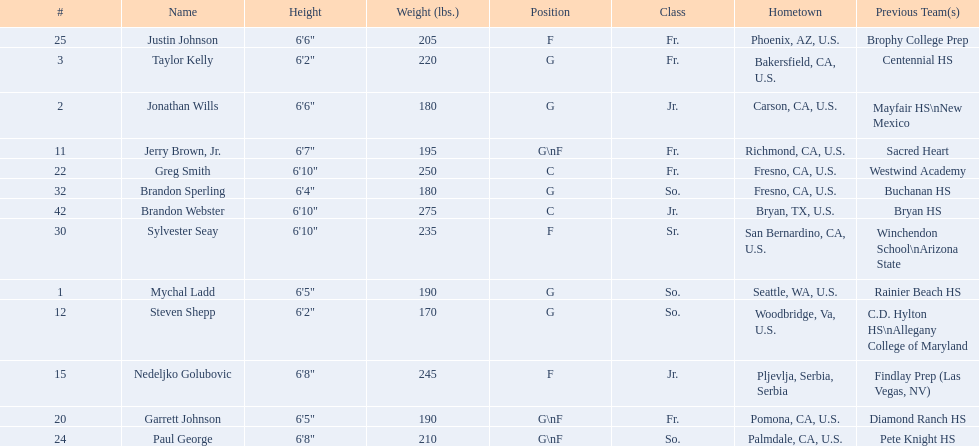Who are the players for the 2009-10 fresno state bulldogs men's basketball team? Mychal Ladd, Jonathan Wills, Taylor Kelly, Jerry Brown, Jr., Steven Shepp, Nedeljko Golubovic, Garrett Johnson, Greg Smith, Paul George, Justin Johnson, Sylvester Seay, Brandon Sperling, Brandon Webster. What are their heights? 6'5", 6'6", 6'2", 6'7", 6'2", 6'8", 6'5", 6'10", 6'8", 6'6", 6'10", 6'4", 6'10". Can you give me this table as a dict? {'header': ['#', 'Name', 'Height', 'Weight (lbs.)', 'Position', 'Class', 'Hometown', 'Previous Team(s)'], 'rows': [['25', 'Justin Johnson', '6\'6"', '205', 'F', 'Fr.', 'Phoenix, AZ, U.S.', 'Brophy College Prep'], ['3', 'Taylor Kelly', '6\'2"', '220', 'G', 'Fr.', 'Bakersfield, CA, U.S.', 'Centennial HS'], ['2', 'Jonathan Wills', '6\'6"', '180', 'G', 'Jr.', 'Carson, CA, U.S.', 'Mayfair HS\\nNew Mexico'], ['11', 'Jerry Brown, Jr.', '6\'7"', '195', 'G\\nF', 'Fr.', 'Richmond, CA, U.S.', 'Sacred Heart'], ['22', 'Greg Smith', '6\'10"', '250', 'C', 'Fr.', 'Fresno, CA, U.S.', 'Westwind Academy'], ['32', 'Brandon Sperling', '6\'4"', '180', 'G', 'So.', 'Fresno, CA, U.S.', 'Buchanan HS'], ['42', 'Brandon Webster', '6\'10"', '275', 'C', 'Jr.', 'Bryan, TX, U.S.', 'Bryan HS'], ['30', 'Sylvester Seay', '6\'10"', '235', 'F', 'Sr.', 'San Bernardino, CA, U.S.', 'Winchendon School\\nArizona State'], ['1', 'Mychal Ladd', '6\'5"', '190', 'G', 'So.', 'Seattle, WA, U.S.', 'Rainier Beach HS'], ['12', 'Steven Shepp', '6\'2"', '170', 'G', 'So.', 'Woodbridge, Va, U.S.', 'C.D. Hylton HS\\nAllegany College of Maryland'], ['15', 'Nedeljko Golubovic', '6\'8"', '245', 'F', 'Jr.', 'Pljevlja, Serbia, Serbia', 'Findlay Prep (Las Vegas, NV)'], ['20', 'Garrett Johnson', '6\'5"', '190', 'G\\nF', 'Fr.', 'Pomona, CA, U.S.', 'Diamond Ranch HS'], ['24', 'Paul George', '6\'8"', '210', 'G\\nF', 'So.', 'Palmdale, CA, U.S.', 'Pete Knight HS']]} What is the shortest height? 6'2", 6'2". What is the lowest weight? 6'2". Which player is it? Steven Shepp. 